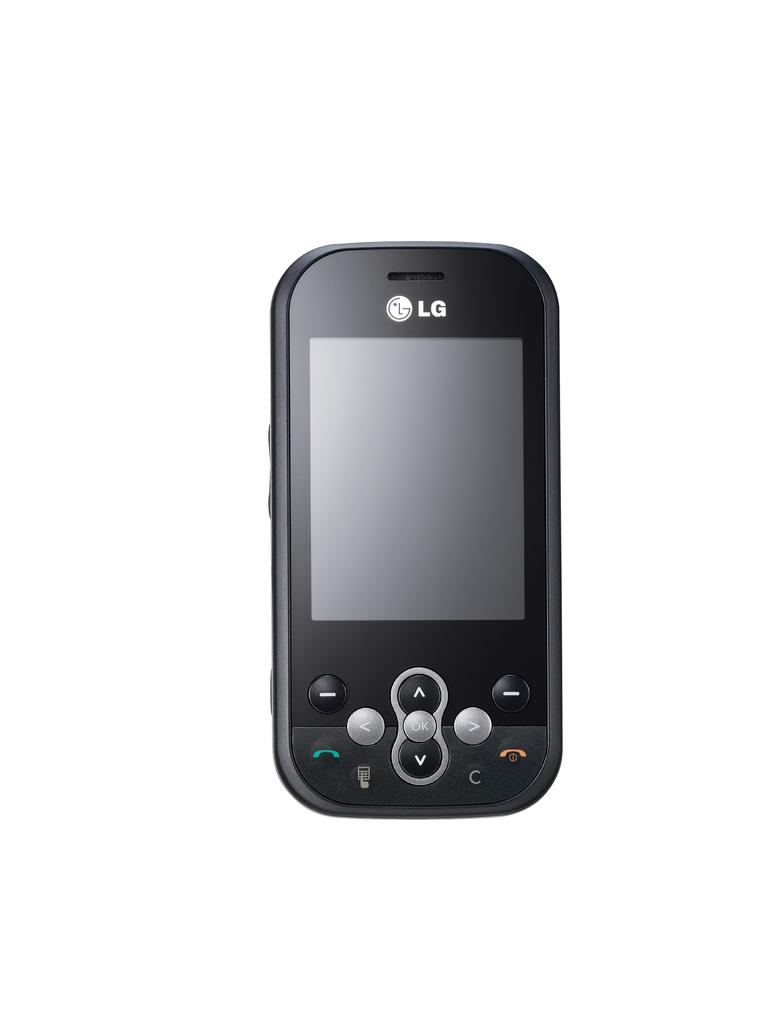Provide a one-sentence caption for the provided image. A lg model following is looking towards a consumer the screen offers a small keyboard for up and down underneath it. 